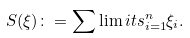Convert formula to latex. <formula><loc_0><loc_0><loc_500><loc_500>S ( \xi ) \colon = \sum \lim i t s _ { i = 1 } ^ { n } \xi _ { i } .</formula> 